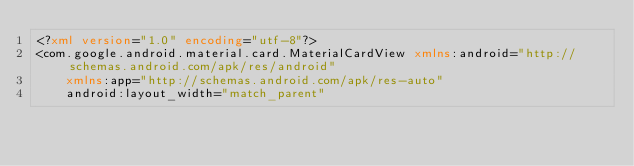<code> <loc_0><loc_0><loc_500><loc_500><_XML_><?xml version="1.0" encoding="utf-8"?>
<com.google.android.material.card.MaterialCardView xmlns:android="http://schemas.android.com/apk/res/android"
    xmlns:app="http://schemas.android.com/apk/res-auto"
    android:layout_width="match_parent"</code> 